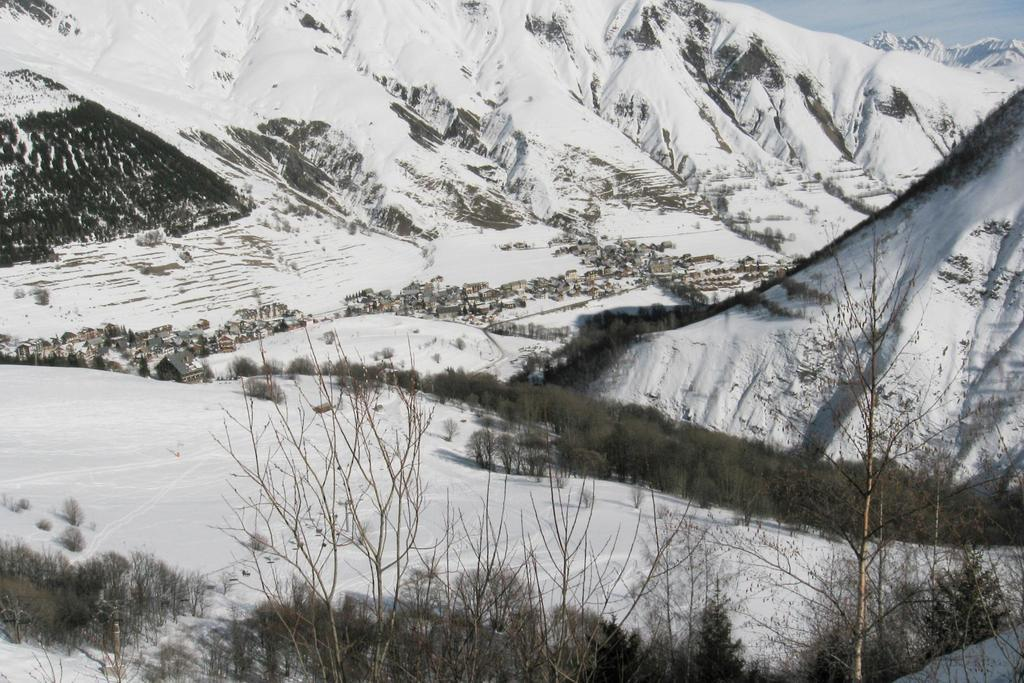What type of natural formations are present in the image? There are ice mountains in the image. What type of vegetation can be seen in the image? There are bushes and plants in the image. What type of human-made structures are present in the image? There are houses in the image. How many children are playing with a match in the image? There are no children or matches present in the image. What type of boats can be seen sailing in the image? There are no boats present in the image. 